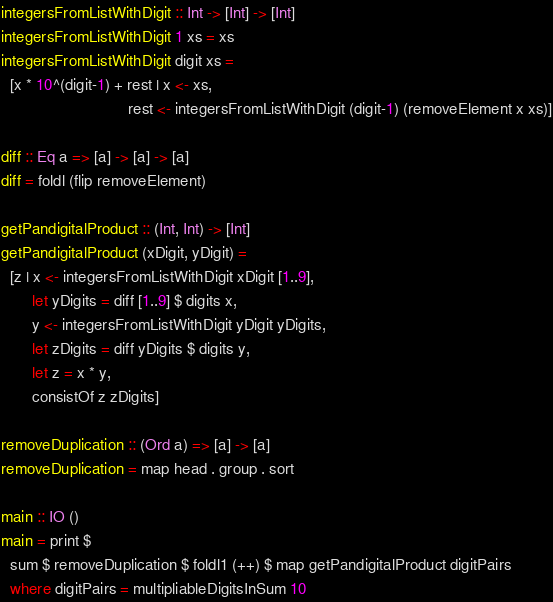Convert code to text. <code><loc_0><loc_0><loc_500><loc_500><_Haskell_>
integersFromListWithDigit :: Int -> [Int] -> [Int]
integersFromListWithDigit 1 xs = xs
integersFromListWithDigit digit xs =
  [x * 10^(digit-1) + rest | x <- xs,
                             rest <- integersFromListWithDigit (digit-1) (removeElement x xs)]

diff :: Eq a => [a] -> [a] -> [a]
diff = foldl (flip removeElement)

getPandigitalProduct :: (Int, Int) -> [Int]
getPandigitalProduct (xDigit, yDigit) =
  [z | x <- integersFromListWithDigit xDigit [1..9],
       let yDigits = diff [1..9] $ digits x,
       y <- integersFromListWithDigit yDigit yDigits,
       let zDigits = diff yDigits $ digits y,
       let z = x * y,
       consistOf z zDigits]

removeDuplication :: (Ord a) => [a] -> [a]
removeDuplication = map head . group . sort

main :: IO ()
main = print $
  sum $ removeDuplication $ foldl1 (++) $ map getPandigitalProduct digitPairs
  where digitPairs = multipliableDigitsInSum 10
</code> 